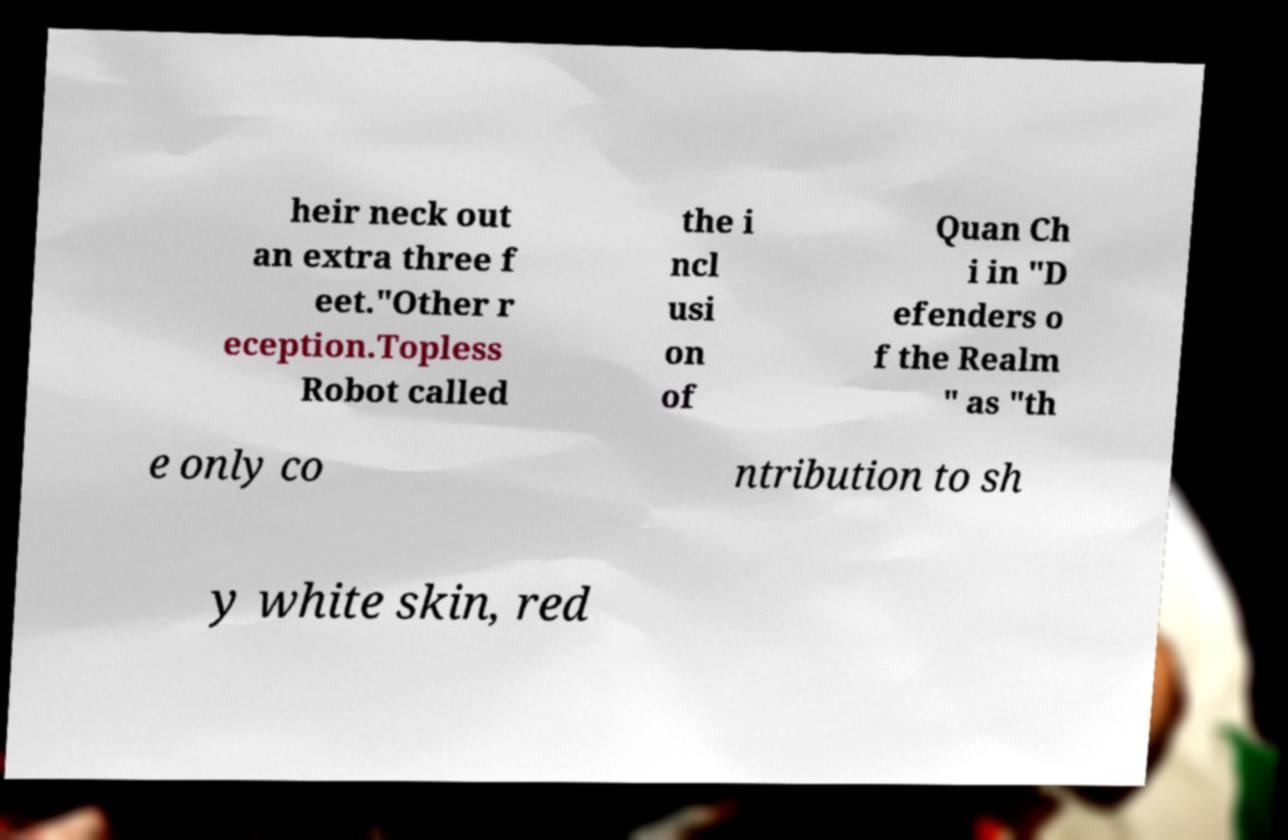Please identify and transcribe the text found in this image. heir neck out an extra three f eet."Other r eception.Topless Robot called the i ncl usi on of Quan Ch i in "D efenders o f the Realm " as "th e only co ntribution to sh y white skin, red 